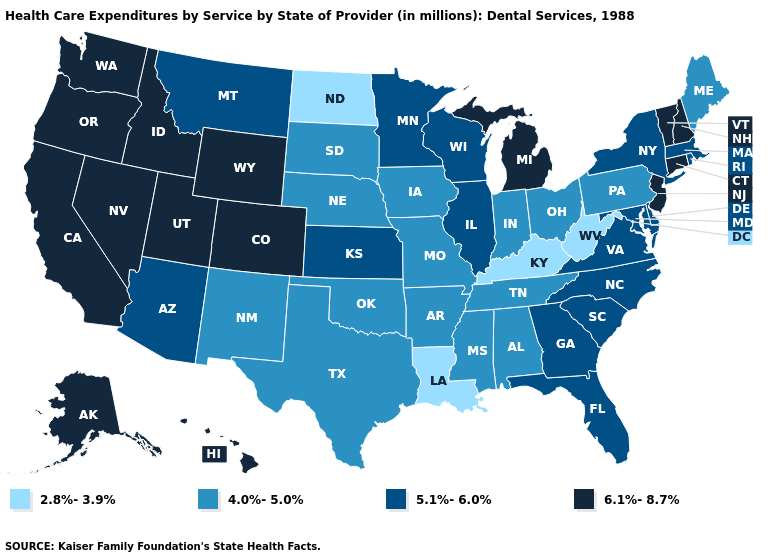What is the value of Pennsylvania?
Be succinct. 4.0%-5.0%. What is the highest value in the USA?
Concise answer only. 6.1%-8.7%. Does Maryland have the highest value in the South?
Write a very short answer. Yes. How many symbols are there in the legend?
Answer briefly. 4. Among the states that border Rhode Island , does Connecticut have the highest value?
Write a very short answer. Yes. How many symbols are there in the legend?
Answer briefly. 4. Does the map have missing data?
Be succinct. No. Does Oregon have the same value as Louisiana?
Keep it brief. No. Is the legend a continuous bar?
Give a very brief answer. No. What is the value of California?
Be succinct. 6.1%-8.7%. Does the map have missing data?
Answer briefly. No. Name the states that have a value in the range 5.1%-6.0%?
Answer briefly. Arizona, Delaware, Florida, Georgia, Illinois, Kansas, Maryland, Massachusetts, Minnesota, Montana, New York, North Carolina, Rhode Island, South Carolina, Virginia, Wisconsin. What is the value of Arkansas?
Concise answer only. 4.0%-5.0%. Name the states that have a value in the range 6.1%-8.7%?
Short answer required. Alaska, California, Colorado, Connecticut, Hawaii, Idaho, Michigan, Nevada, New Hampshire, New Jersey, Oregon, Utah, Vermont, Washington, Wyoming. What is the value of Mississippi?
Concise answer only. 4.0%-5.0%. 